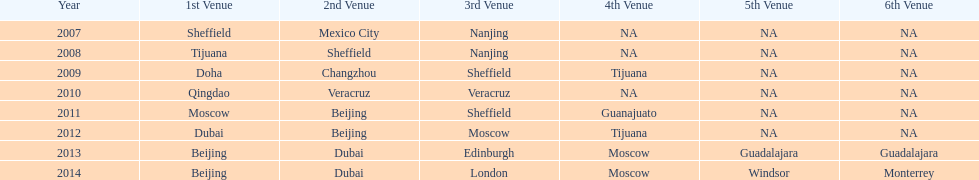Which two venue has no nations from 2007-2012 5th Venue, 6th Venue. 